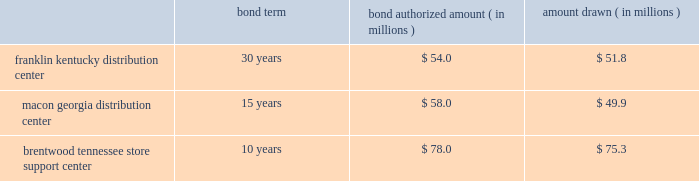The company entered into agreements with various governmental entities in the states of kentucky , georgia and tennessee to implement tax abatement plans related to its distribution center in franklin , kentucky ( simpson county ) , its distribution center in macon , georgia ( bibb county ) , and its store support center in brentwood , tennessee ( williamson county ) .
The tax abatement plans provide for reduction of real property taxes for specified time frames by legally transferring title to its real property in exchange for industrial revenue bonds .
This property was then leased back to the company .
No cash was exchanged .
The lease payments are equal to the amount of the payments on the bonds .
The tax abatement period extends through the term of the lease , which coincides with the maturity date of the bonds .
At any time , the company has the option to purchase the real property by paying off the bonds , plus $ 1 .
The terms and amounts authorized and drawn under each industrial revenue bond agreement are outlined as follows , as of december 30 , 2017 : bond term bond authorized amount ( in millions ) amount drawn ( in millions ) .
Due to the form of these transactions , the company has not recorded the bonds or the lease obligation associated with the sale lease-back transaction .
The original cost of the company 2019s property and equipment is recorded on the balance sheet and is being depreciated over its estimated useful life .
Capitalized software costs the company capitalizes certain costs related to the acquisition and development of software and amortizes these costs using the straight-line method over the estimated useful life of the software , which is three to five years .
Computer software consists of software developed for internal use and third-party software purchased for internal use .
A subsequent addition , modification or upgrade to internal-use software is capitalized to the extent that it enhances the software 2019s functionality or extends its useful life .
These costs are included in computer software and hardware in the accompanying consolidated balance sheets .
Certain software costs not meeting the criteria for capitalization are expensed as incurred .
Store closing costs the company regularly evaluates the performance of its stores and periodically closes those that are under-performing .
The company records a liability for costs associated with an exit or disposal activity when the liability is incurred , usually in the period the store closes .
Store closing costs were not significant to the results of operations for any of the fiscal years presented .
Leases assets under capital leases are amortized in accordance with the company 2019s normal depreciation policy for owned assets or over the lease term , if shorter , and the related charge to operations is included in depreciation expense in the consolidated statements of income .
Certain operating leases include rent increases during the lease term .
For these leases , the company recognizes the related rental expense on a straight-line basis over the term of the lease ( which includes the pre-opening period of construction , renovation , fixturing and merchandise placement ) and records the difference between the expense charged to operations and amounts paid as a deferred rent liability .
The company occasionally receives reimbursements from landlords to be used towards improving the related store to be leased .
Leasehold improvements are recorded at their gross costs , including items reimbursed by landlords .
Related reimbursements are deferred and amortized on a straight-line basis as a reduction of rent expense over the applicable lease term .
Note 2 - share-based compensation : share-based compensation includes stock option and restricted stock unit awards and certain transactions under the company 2019s espp .
Share-based compensation expense is recognized based on the grant date fair value of all stock option and restricted stock unit awards plus a discount on shares purchased by employees as a part of the espp .
The discount under the espp represents the difference between the purchase date market value and the employee 2019s purchase price. .
As of december 312017 what was the percent of the amount drawn to the amount authorized for the franklin kentucky distribution center? 
Computations: (51.8 / 54.0)
Answer: 0.95926. 